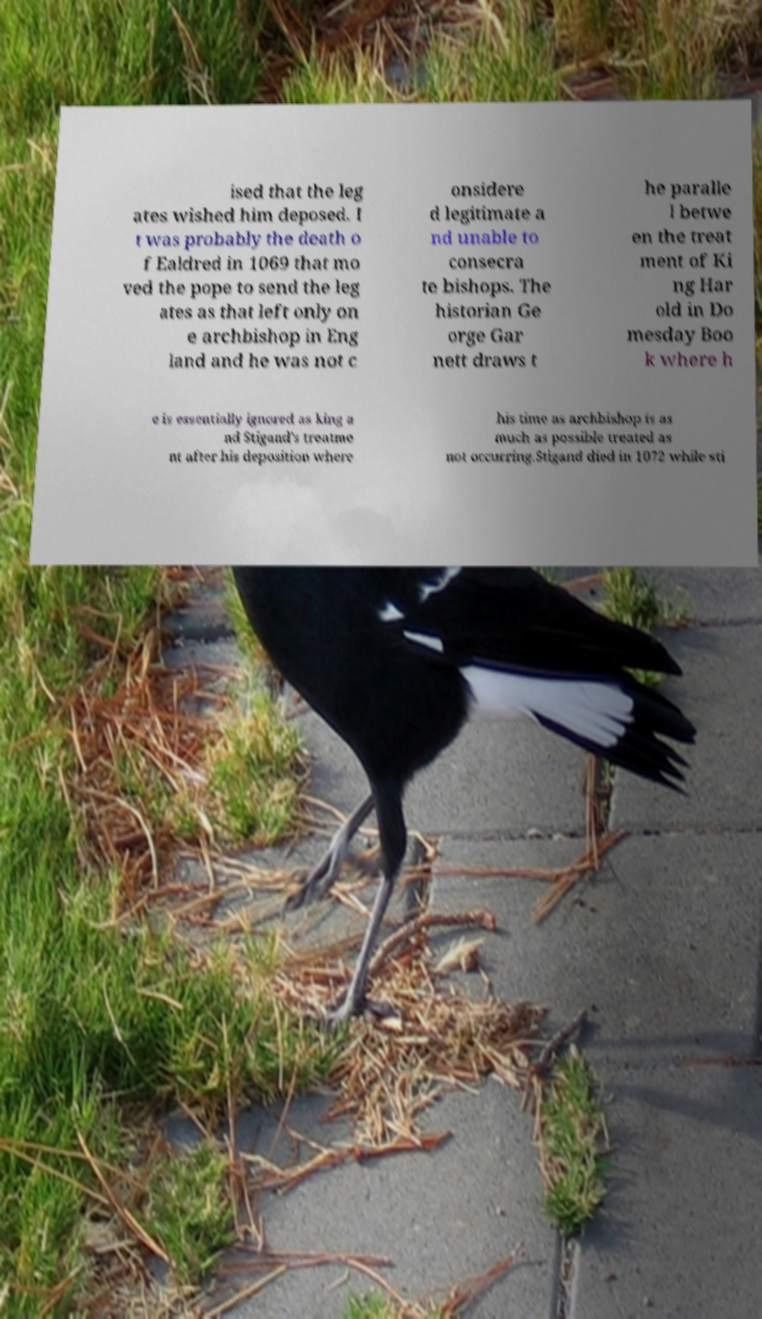Could you extract and type out the text from this image? ised that the leg ates wished him deposed. I t was probably the death o f Ealdred in 1069 that mo ved the pope to send the leg ates as that left only on e archbishop in Eng land and he was not c onsidere d legitimate a nd unable to consecra te bishops. The historian Ge orge Gar nett draws t he paralle l betwe en the treat ment of Ki ng Har old in Do mesday Boo k where h e is essentially ignored as king a nd Stigand's treatme nt after his deposition where his time as archbishop is as much as possible treated as not occurring.Stigand died in 1072 while sti 